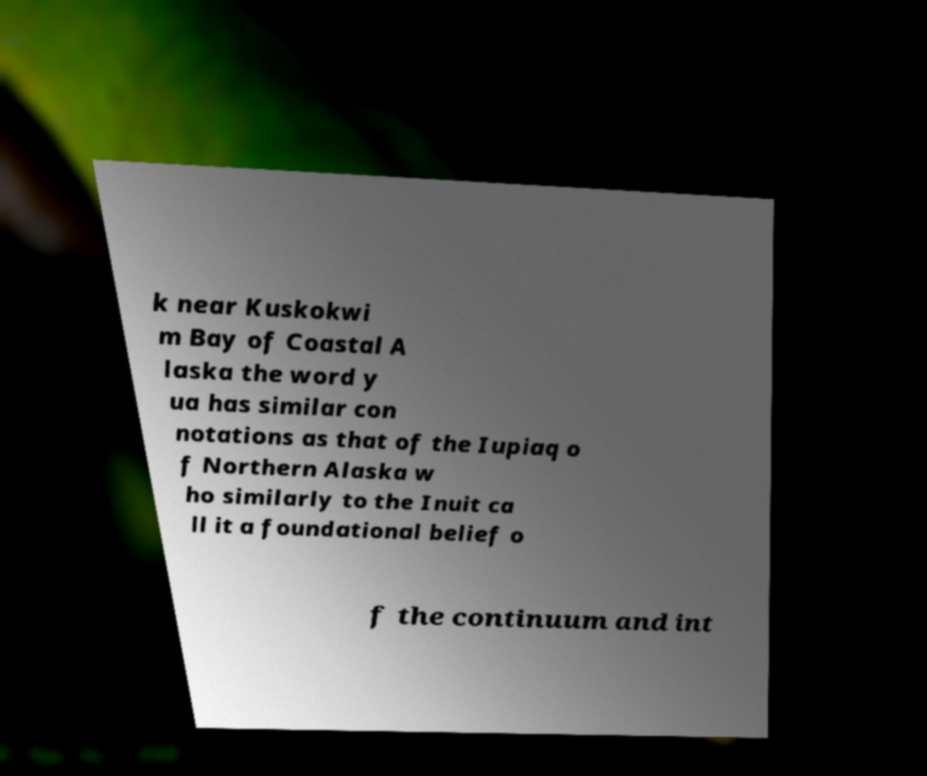Can you read and provide the text displayed in the image?This photo seems to have some interesting text. Can you extract and type it out for me? k near Kuskokwi m Bay of Coastal A laska the word y ua has similar con notations as that of the Iupiaq o f Northern Alaska w ho similarly to the Inuit ca ll it a foundational belief o f the continuum and int 